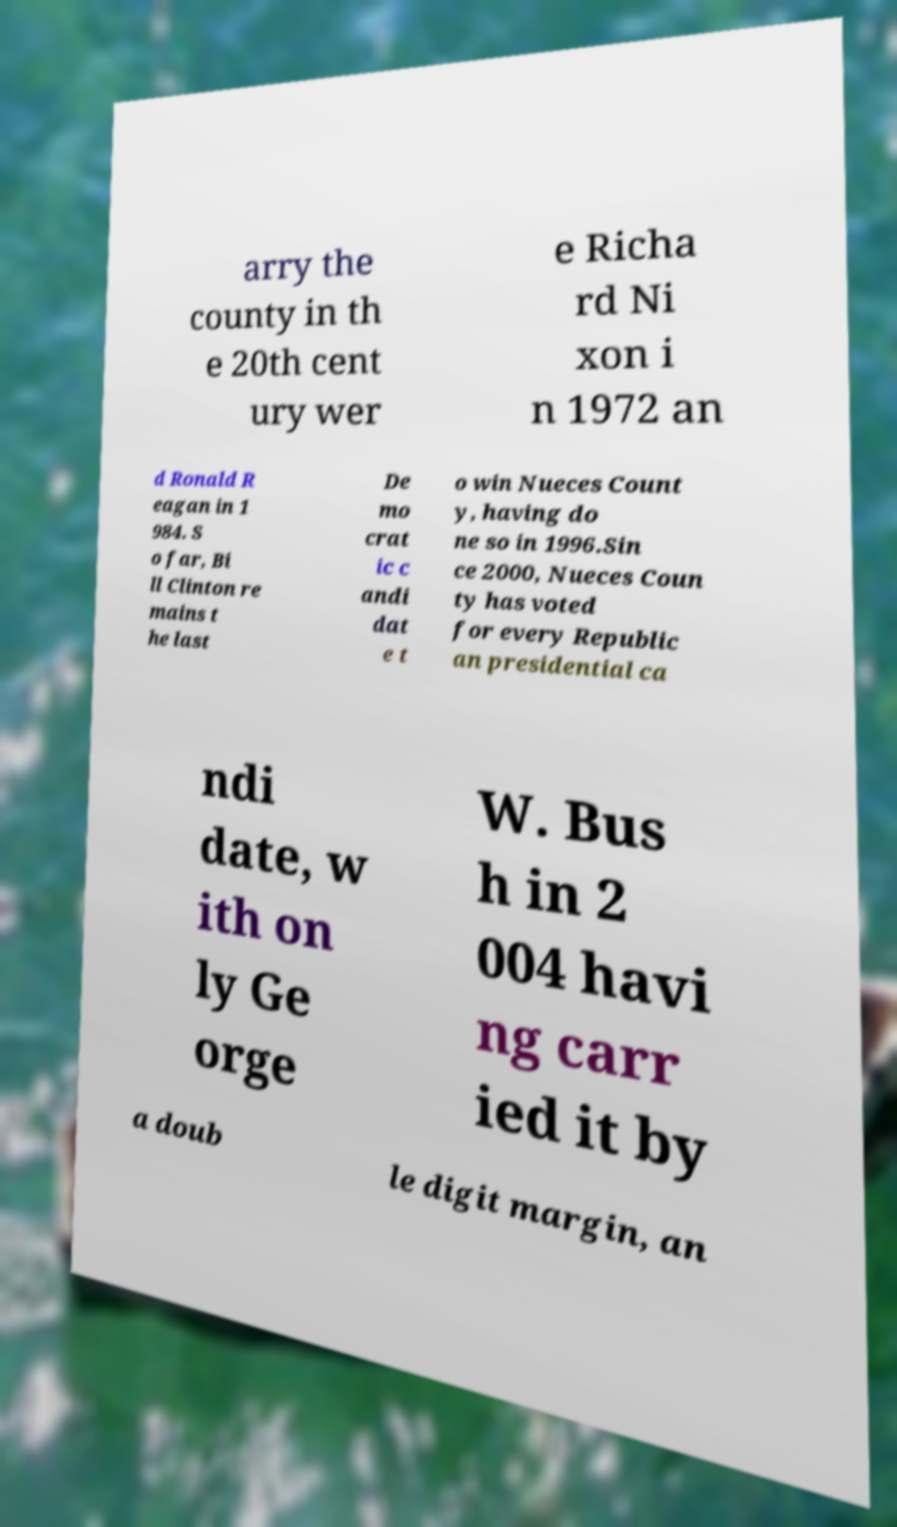For documentation purposes, I need the text within this image transcribed. Could you provide that? arry the county in th e 20th cent ury wer e Richa rd Ni xon i n 1972 an d Ronald R eagan in 1 984. S o far, Bi ll Clinton re mains t he last De mo crat ic c andi dat e t o win Nueces Count y, having do ne so in 1996.Sin ce 2000, Nueces Coun ty has voted for every Republic an presidential ca ndi date, w ith on ly Ge orge W. Bus h in 2 004 havi ng carr ied it by a doub le digit margin, an 